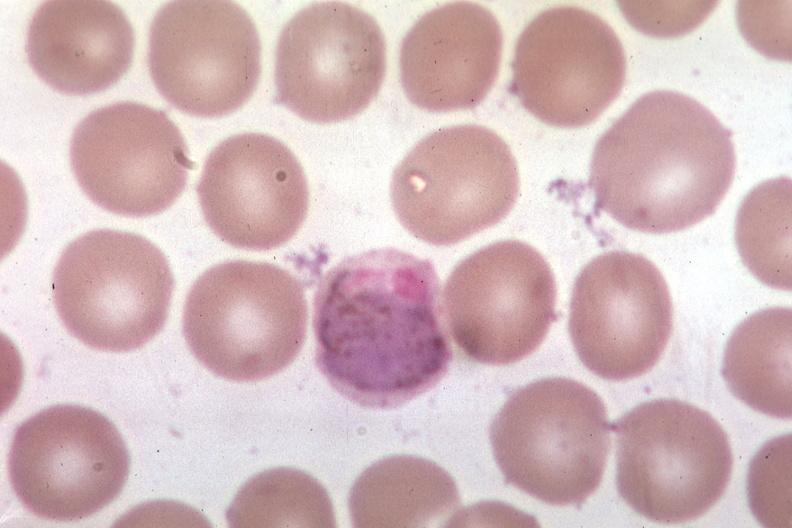what is present?
Answer the question using a single word or phrase. Blood 